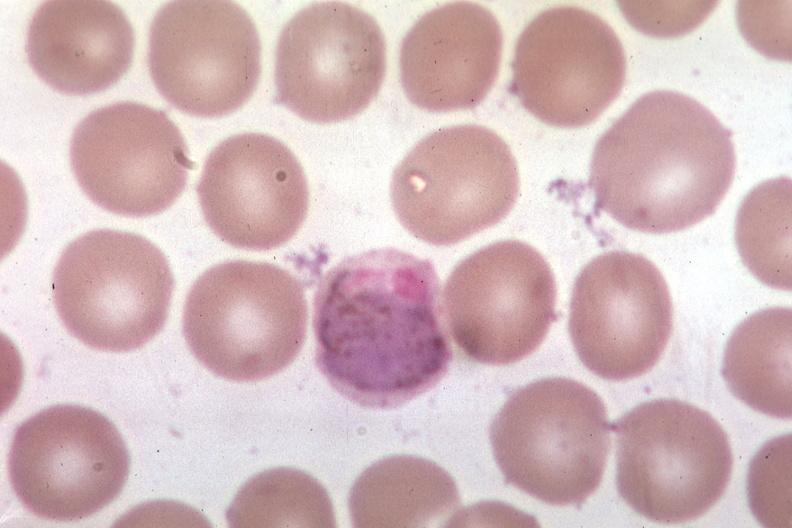what is present?
Answer the question using a single word or phrase. Blood 